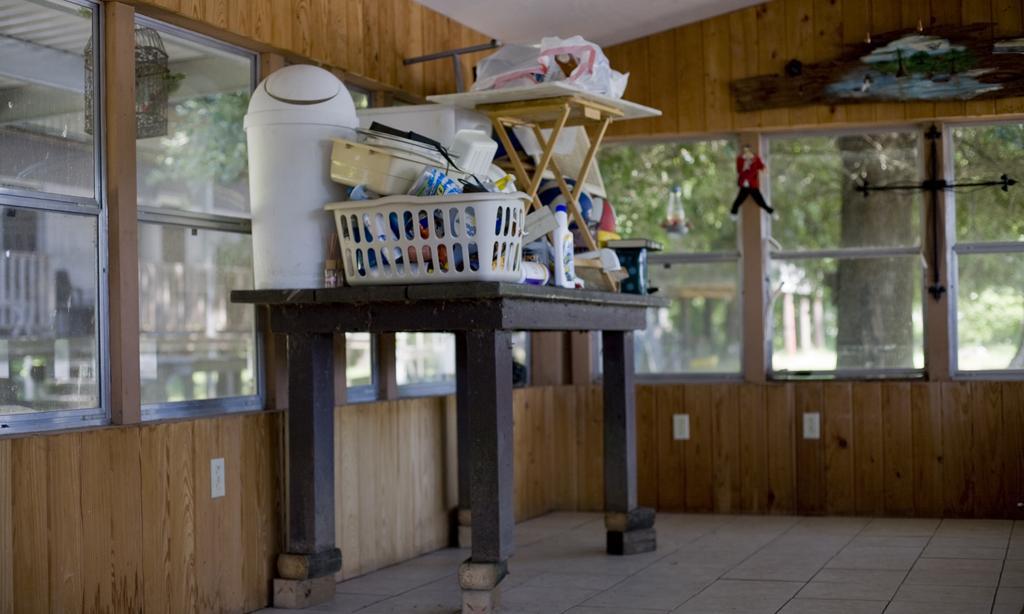Please provide a concise description of this image. In this image in the center there is one table, on the table there is one basket, dustbin, table, cover, bottle, book and some objects. And in the background there is a glass window and wooden wall and also some trees, at the bottom there is a floor. 